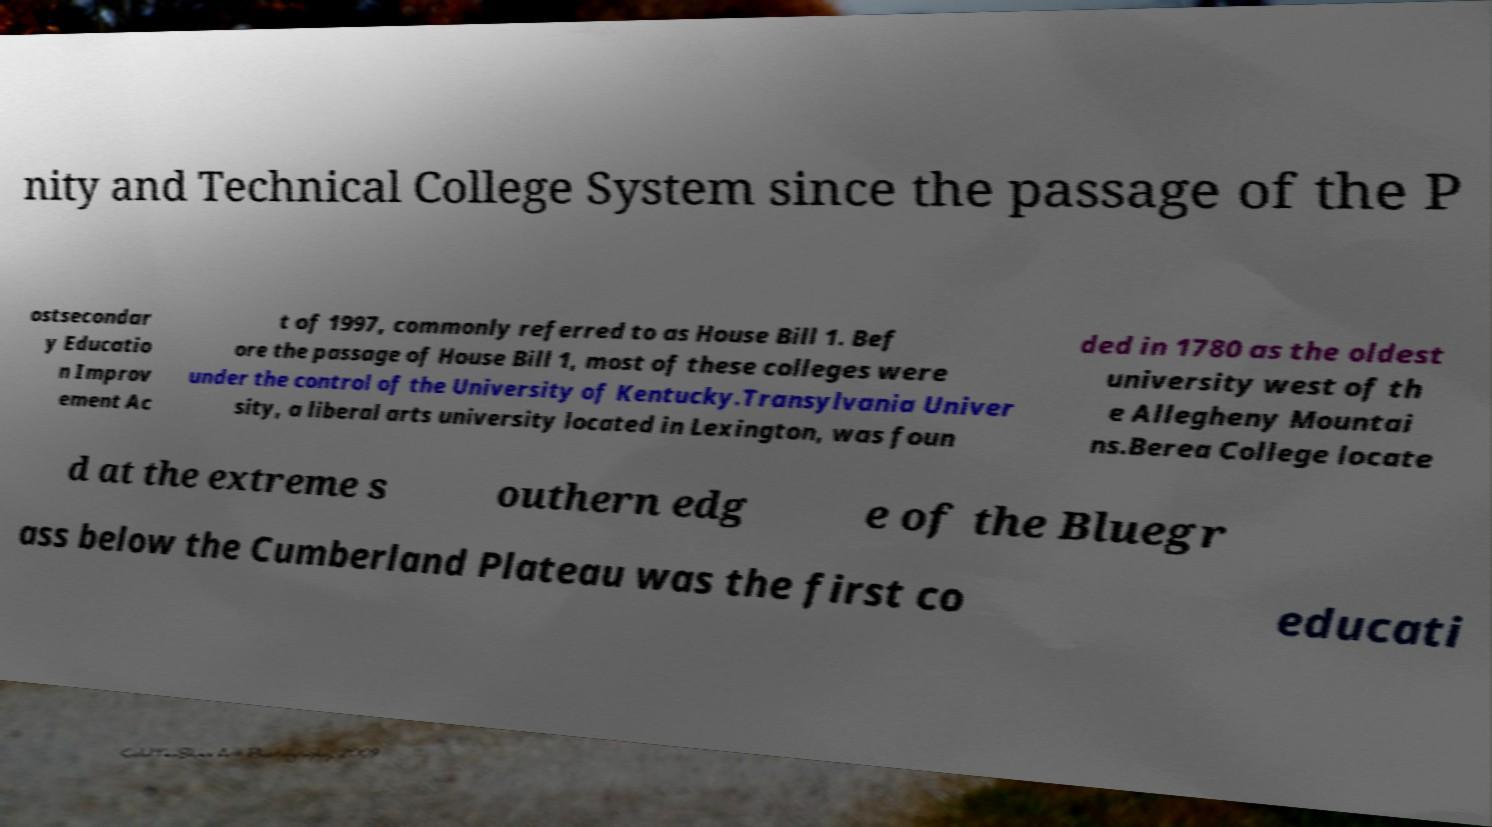For documentation purposes, I need the text within this image transcribed. Could you provide that? nity and Technical College System since the passage of the P ostsecondar y Educatio n Improv ement Ac t of 1997, commonly referred to as House Bill 1. Bef ore the passage of House Bill 1, most of these colleges were under the control of the University of Kentucky.Transylvania Univer sity, a liberal arts university located in Lexington, was foun ded in 1780 as the oldest university west of th e Allegheny Mountai ns.Berea College locate d at the extreme s outhern edg e of the Bluegr ass below the Cumberland Plateau was the first co educati 